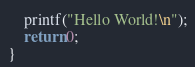Convert code to text. <code><loc_0><loc_0><loc_500><loc_500><_Cuda_>	printf("Hello World!\n");
	return 0;
}
</code> 